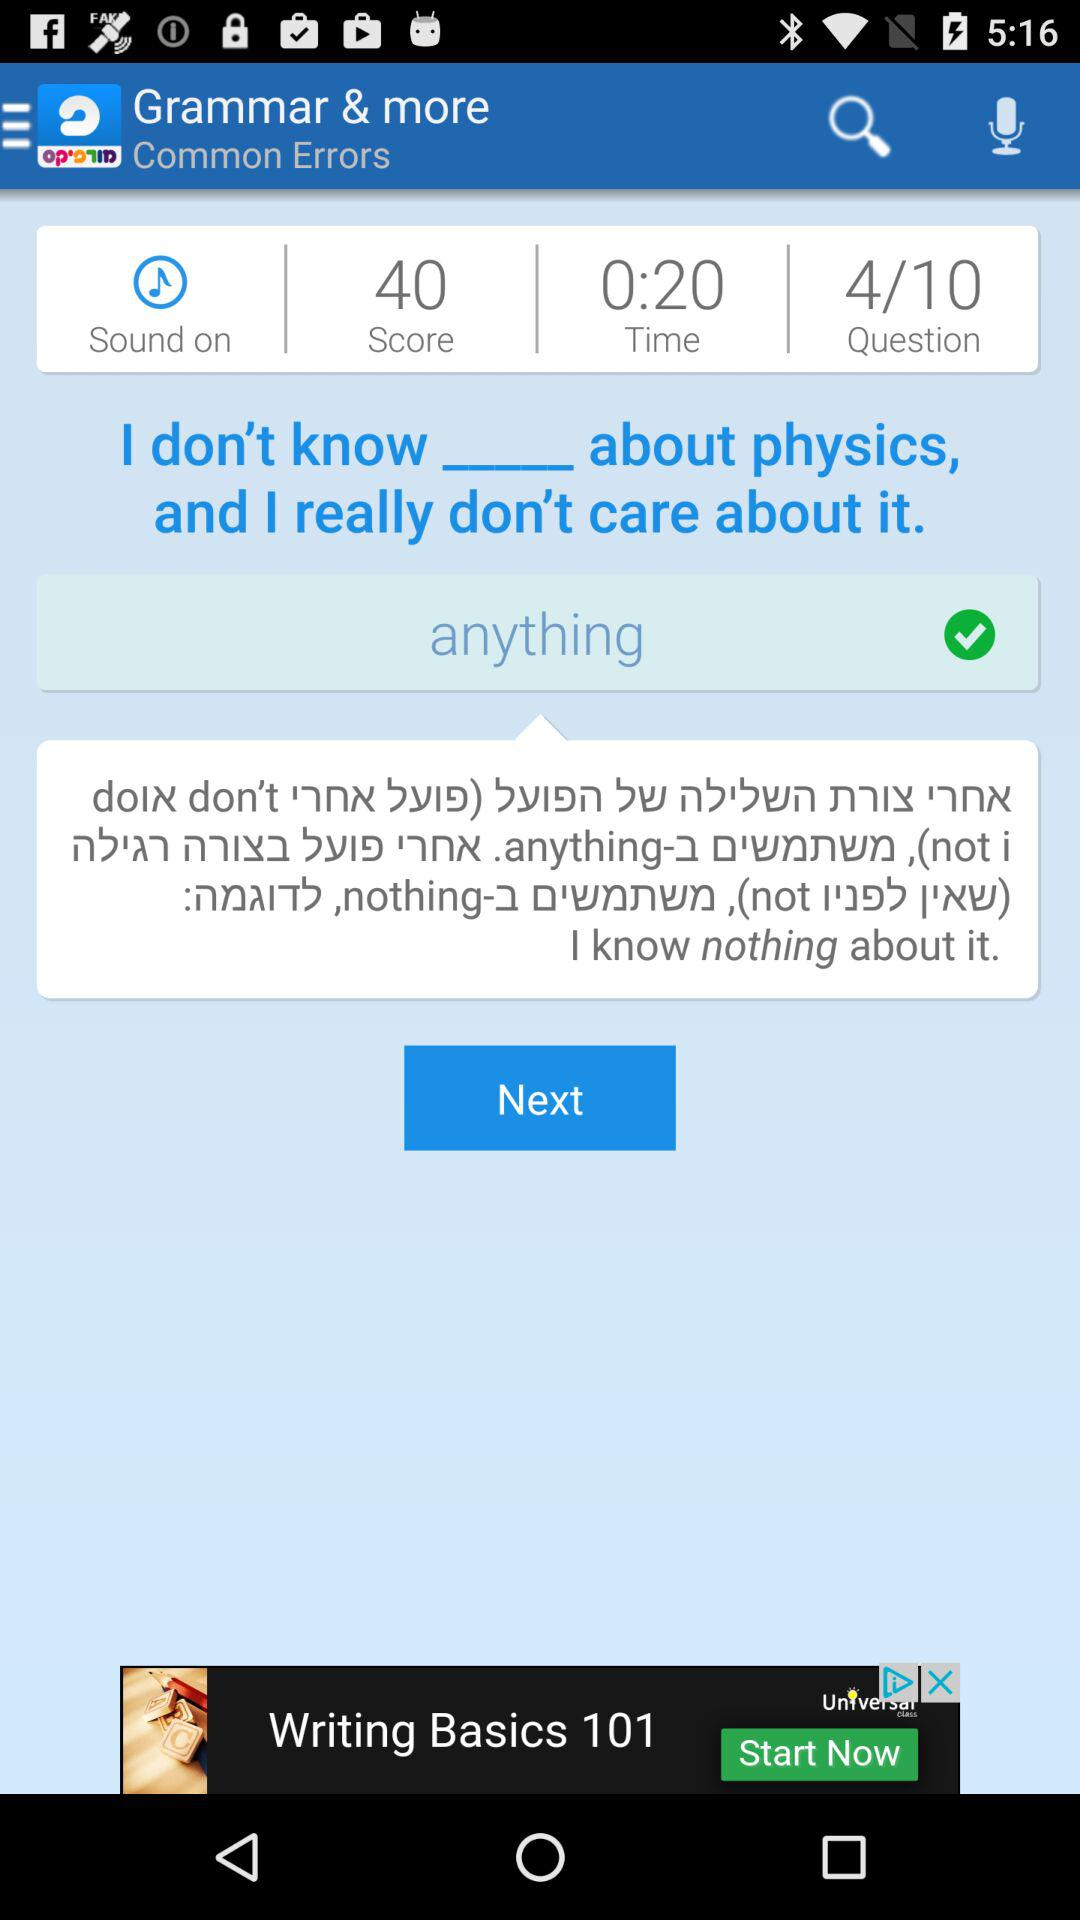What's the score? The score is 40. 